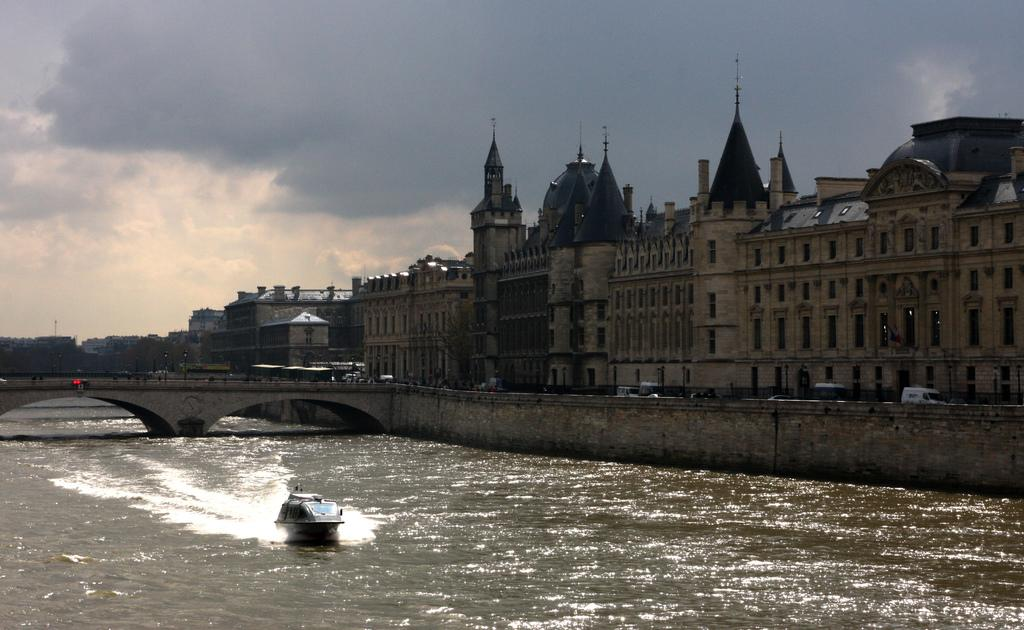What is the main feature of the image? There is water in the image. What is on the water? There is a boat on the water. What other structures are present in the image? There is a bridge and buildings in the image. What can be seen on the buildings? There are windows visible on the buildings. How would you describe the weather in the image? The sky is cloudy in the image. Where is the giraffe standing in the image? There is no giraffe present in the image. What color is the spot on the bridge in the image? There is no spot on the bridge in the image; it is a continuous structure. 